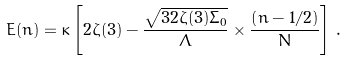Convert formula to latex. <formula><loc_0><loc_0><loc_500><loc_500>E ( n ) = \kappa \left [ 2 \zeta ( 3 ) - \frac { \sqrt { 3 2 \zeta ( 3 ) \Sigma _ { 0 } } } { \Lambda } \times \frac { \left ( n - 1 / 2 \right ) } { N } \right ] \, .</formula> 